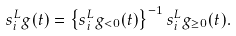<formula> <loc_0><loc_0><loc_500><loc_500>s _ { i } ^ { L } g ( t ) = \left \{ s _ { i } ^ { L } g _ { < 0 } ( t ) \right \} ^ { - 1 } s _ { i } ^ { L } g _ { \geq 0 } ( t ) .</formula> 